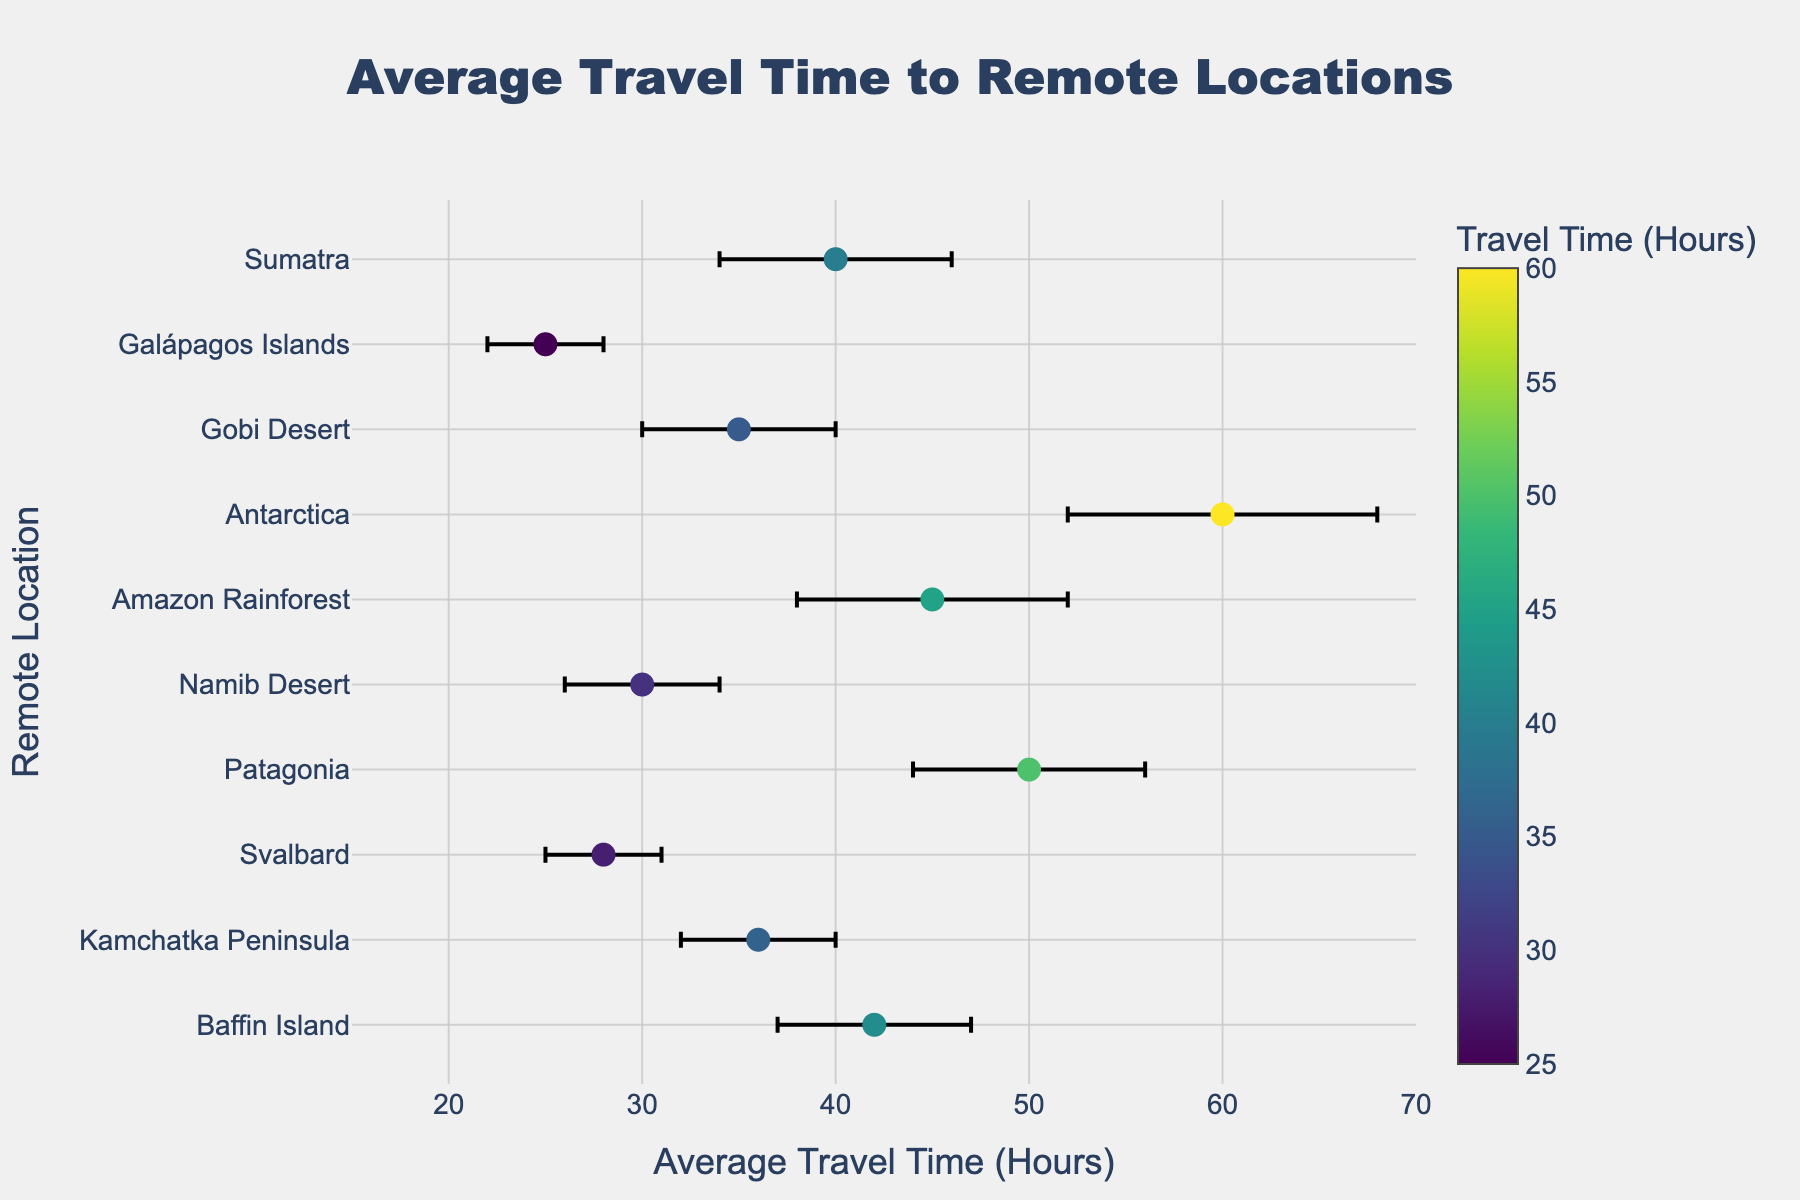What is the title of the figure? The title of the figure is displayed at the top, it reads "Average Travel Time to Remote Locations".
Answer: Average Travel Time to Remote Locations How many remote locations are compared in the figure? By counting the number of data points on the y-axis, we see each point represents a location.
Answer: 10 Which location has the highest average travel time? The location with the highest x-value on the scatter plot indicates the highest average travel time, which is Antarctica.
Answer: Antarctica What is the average travel time to Namib Desert? Locate the Namib Desert on the y-axis and follow its corresponding marker to the x-axis.
Answer: 30 hours Which location has the lowest travel time uncertainty? By observing the length of the error bars, the location with the shortest error bar is Svalbard.
Answer: Svalbard What is the range of average travel times shown in the plot? The smallest and largest x-values represent the range of average travel times: from Galápagos Islands at 25 hours to Antarctica at 60 hours.
Answer: 25 to 60 hours Is Patagonia's travel time greater than Kamchatka Peninsula's travel time? Compare their positions on the x-axis; Patagonia's travel time is to the right of Kamchatka Peninsula, indicating it's greater.
Answer: Yes What is the uncertainty in average travel time estimate for Amazon Rainforest? Find the Amazon Rainforest on the y-axis, and check the length of its error bar displayed in the hover template.
Answer: 7 hours What is the difference in average travel time between Gobi Desert and Sumatra? Locate both locations on the y-axis and find their respective x-values. Subtract Gobi Desert's 35 hours from Sumatra's 40 hours.
Answer: 5 hours (Sumatra is longer) Which location has an average travel time of around 40 hours and what is its uncertainty? Locate the data point near the 40-hour mark along the x-axis, which corresponds to Sumatra, and find its error bar value.
Answer: Sumatra, 6 hours 